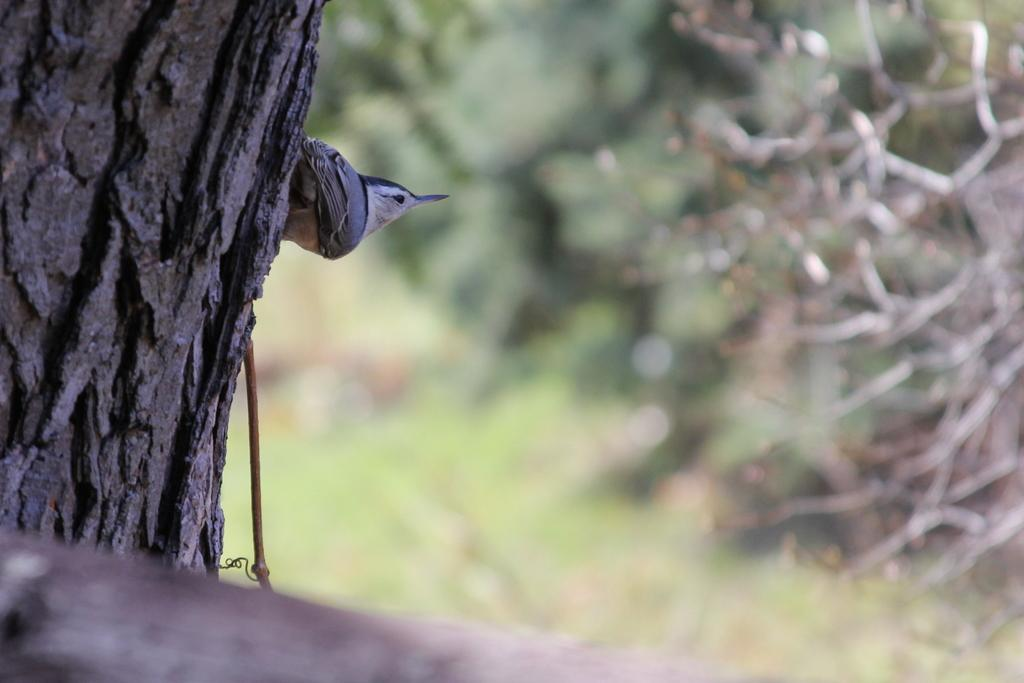What can be seen on the left side of the image? There is a tree trunk and a bird on the left side of the image. How would you describe the background of the image? The background of the image is blurred. What type of vegetation is visible in the background? Plants are visible in the background of the image. What is located at the bottom of the image? There is an object at the bottom of the image. Can you see a banana in the image? There is no banana present in the image. 